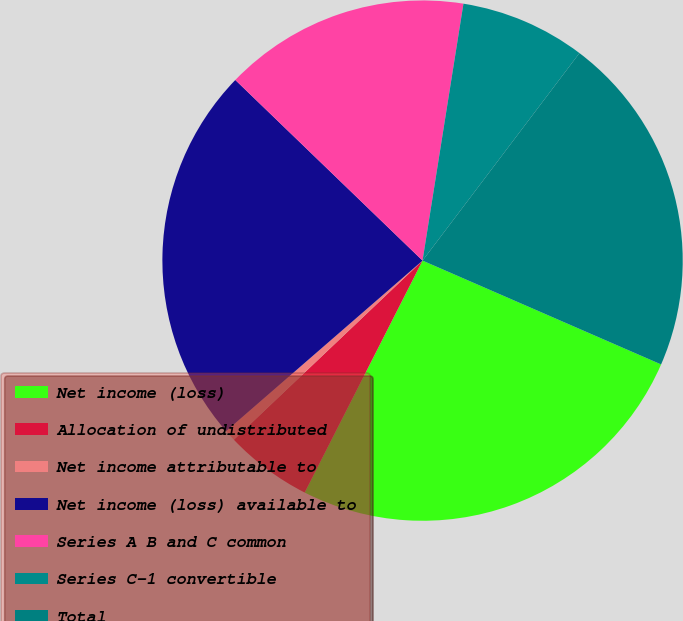Convert chart to OTSL. <chart><loc_0><loc_0><loc_500><loc_500><pie_chart><fcel>Net income (loss)<fcel>Allocation of undistributed<fcel>Net income attributable to<fcel>Net income (loss) available to<fcel>Series A B and C common<fcel>Series C-1 convertible<fcel>Total<nl><fcel>25.95%<fcel>5.43%<fcel>0.71%<fcel>23.59%<fcel>15.3%<fcel>7.79%<fcel>21.23%<nl></chart> 